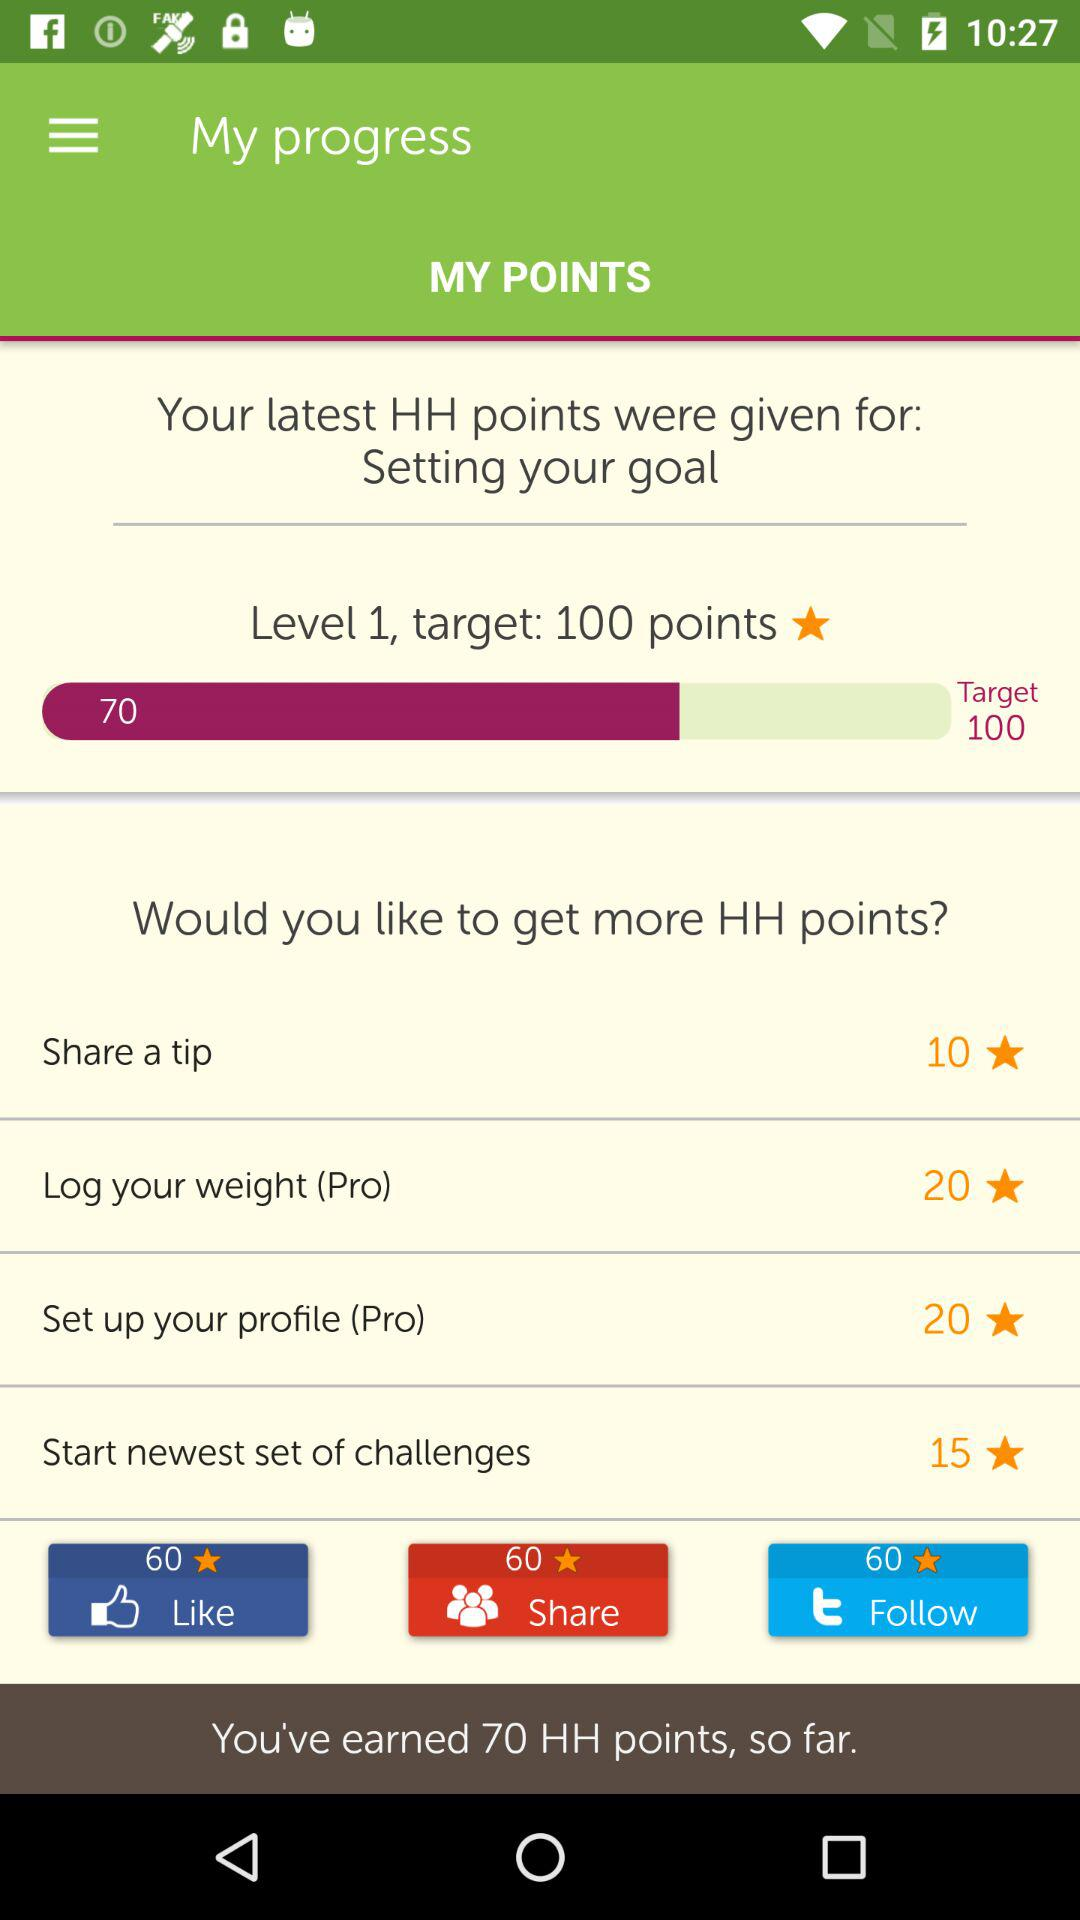How many points are earned? The earned points are 70 HH. 